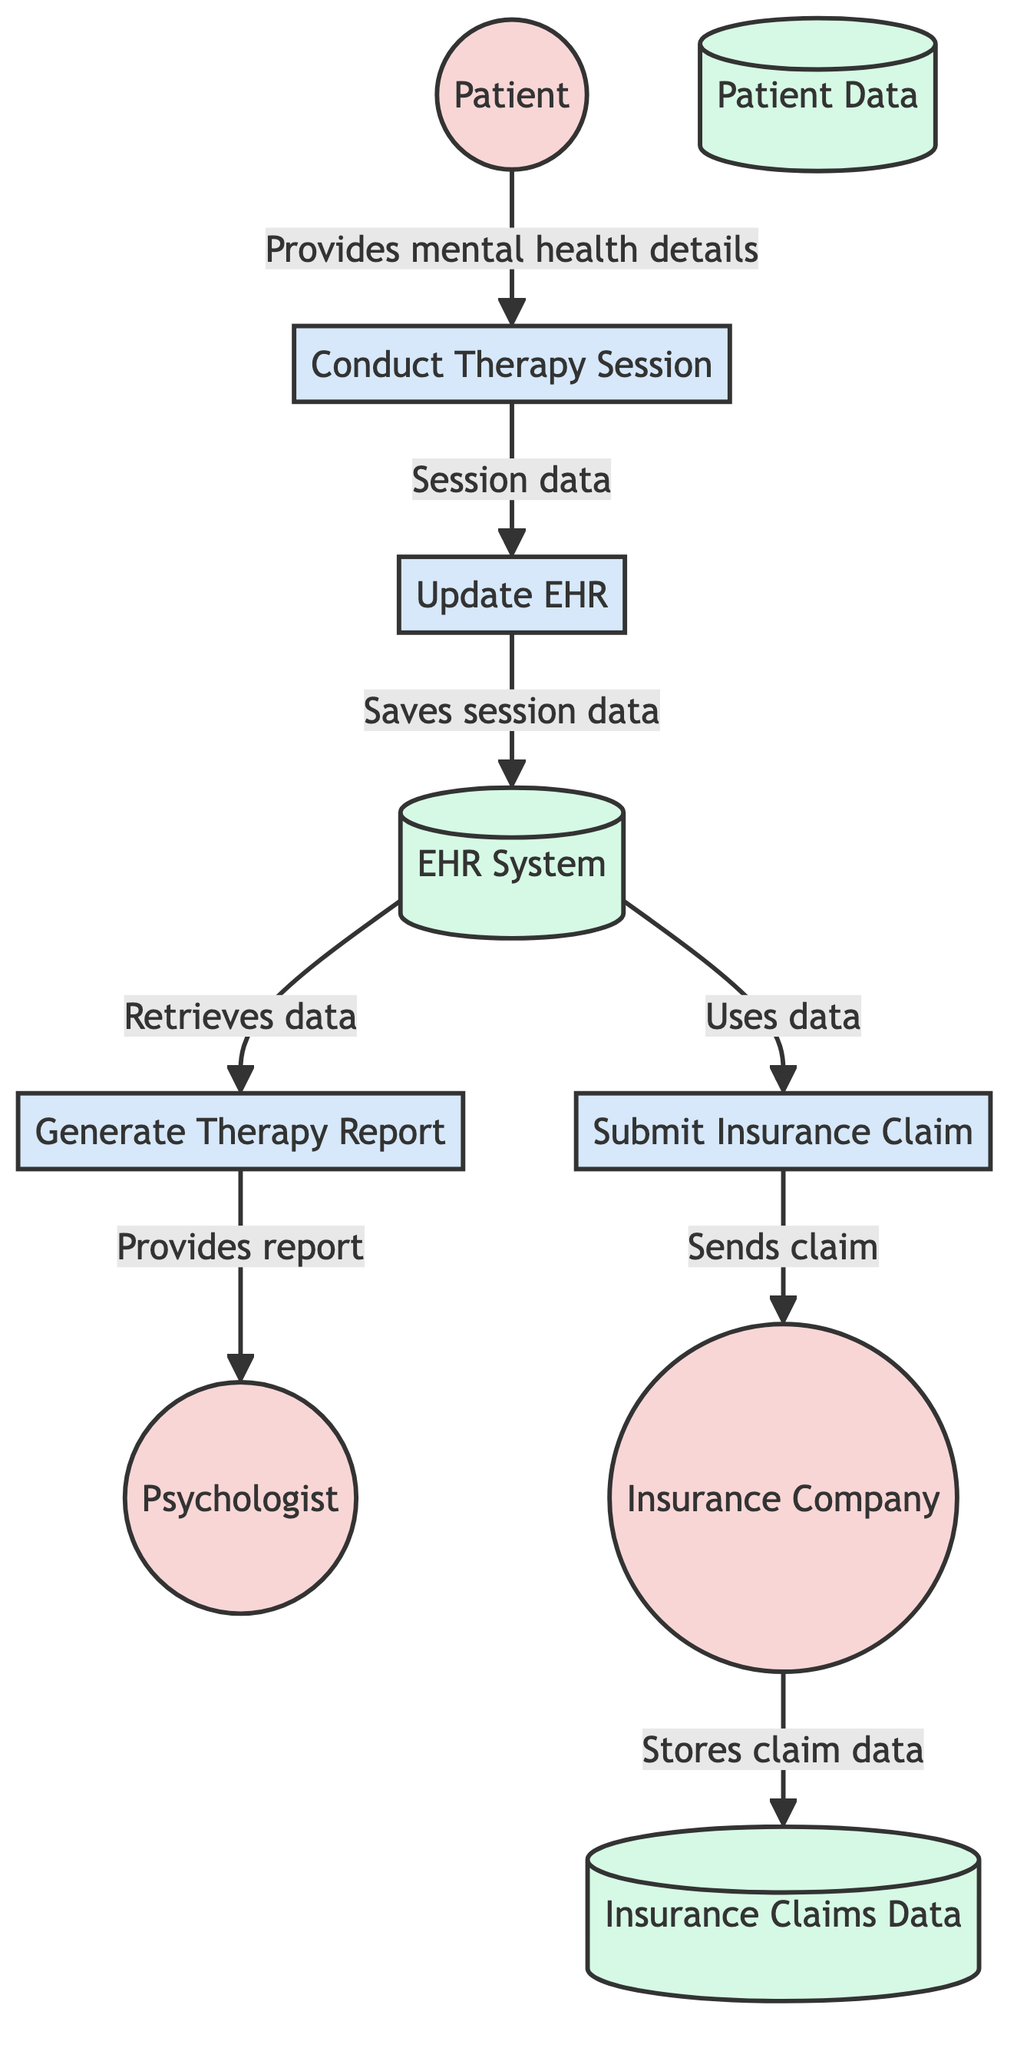What external entity conducts the therapy sessions? The diagram indicates that the external entity responsible for conducting therapy sessions is the "Psychologist". This can be seen in the section listing external entities where "Psychologist" is clearly labeled.
Answer: Psychologist How many processes are represented in the diagram? By counting the labeled processes, we find there are four: "Conduct Therapy Session", "Update EHR", "Generate Therapy Report", and "Submit Insurance Claim". This count directly comes from the processes section of the diagram.
Answer: 4 What is the destination of the data flow from "Update EHR"? The data flow description from "Update EHR" points to its destination as the "EHR System". This is evident from looking at the data flow connections where it shows that the information is saved into "EHR System".
Answer: EHR System Which entity receives the therapy report after it is generated? The diagram shows that the "Generate Therapy Report" process sends the therapy report directly to the "Psychologist". This is illustrated in the data flow where the report is explicitly labeled to go to the psychologist.
Answer: Psychologist What data does the "Submit Insurance Claim" process send? The "Submit Insurance Claim" process sends claim data to the "Insurance Company" as indicated in the diagram. The data flow connection clearly describes that the claim data originates from the submission process.
Answer: Claim data What does "EHR System" store? The "EHR System" stores all electronic health records, including patient therapy session data. This information is stated in the description of the data store section of the diagram.
Answer: Electronic health records What process is initiated after the "Conduct Therapy Session"? After the "Conduct Therapy Session", the next process initiated is "Update EHR". This is shown in the diagram by the direct flow of session data from the therapy session to updating the electronic health record.
Answer: Update EHR What is the outcome of the process "Submit Insurance Claim"? The outcome of the "Submit Insurance Claim" process is that the claim data is sent to the "Insurance Company" for approval, as per the data flow that follows this process.
Answer: Claim data sent to Insurance Company 